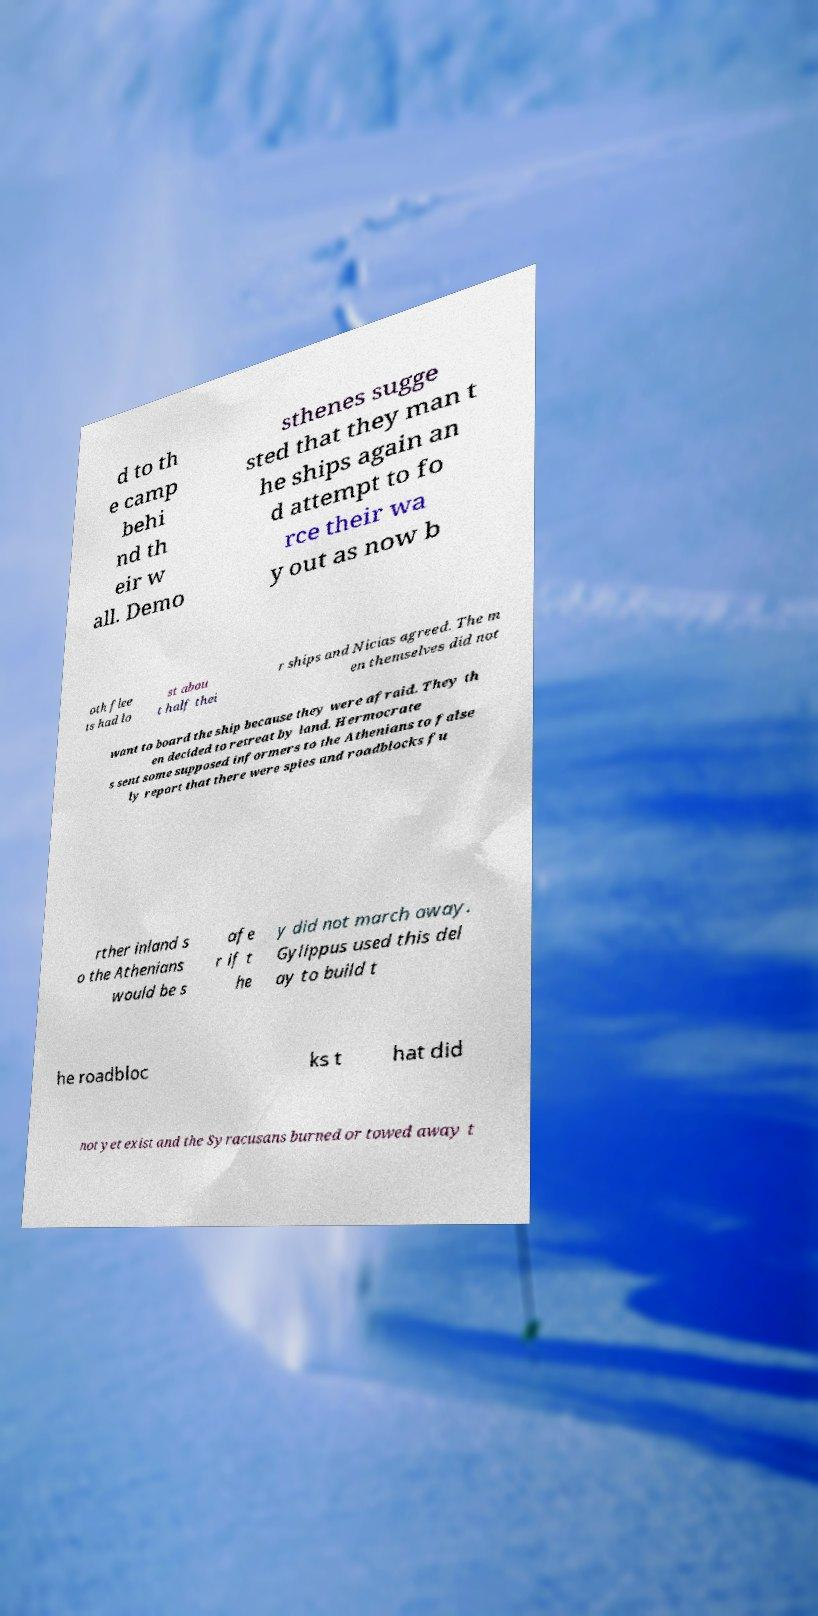For documentation purposes, I need the text within this image transcribed. Could you provide that? d to th e camp behi nd th eir w all. Demo sthenes sugge sted that they man t he ships again an d attempt to fo rce their wa y out as now b oth flee ts had lo st abou t half thei r ships and Nicias agreed. The m en themselves did not want to board the ship because they were afraid. They th en decided to retreat by land. Hermocrate s sent some supposed informers to the Athenians to false ly report that there were spies and roadblocks fu rther inland s o the Athenians would be s afe r if t he y did not march away. Gylippus used this del ay to build t he roadbloc ks t hat did not yet exist and the Syracusans burned or towed away t 